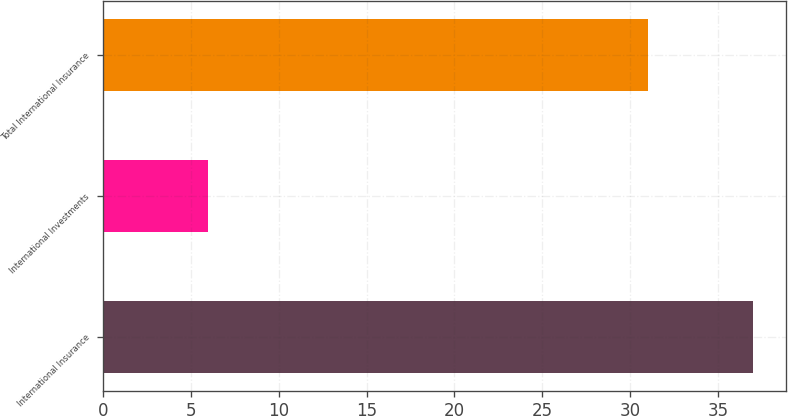Convert chart. <chart><loc_0><loc_0><loc_500><loc_500><bar_chart><fcel>International Insurance<fcel>International Investments<fcel>Total International Insurance<nl><fcel>37<fcel>6<fcel>31<nl></chart> 